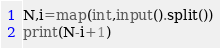<code> <loc_0><loc_0><loc_500><loc_500><_Python_>N,i=map(int,input().split())
print(N-i+1)</code> 